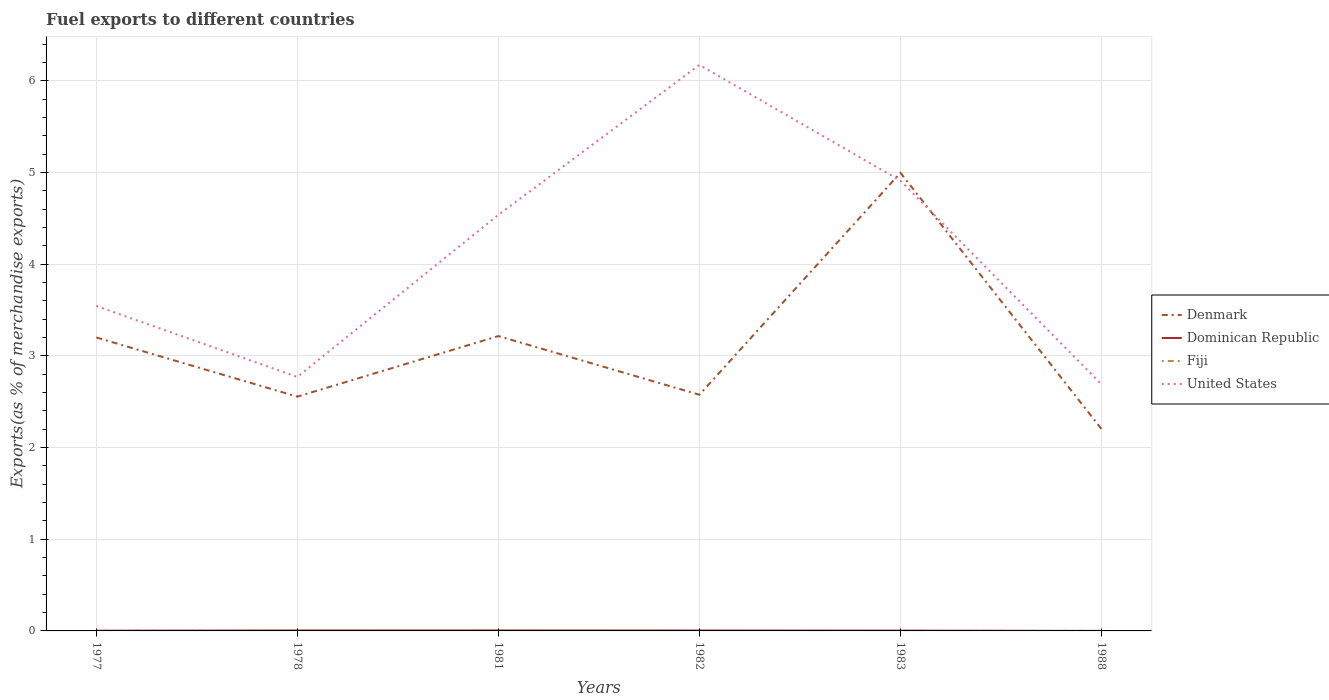How many different coloured lines are there?
Your response must be concise. 4. Does the line corresponding to Fiji intersect with the line corresponding to Dominican Republic?
Provide a short and direct response. Yes. Is the number of lines equal to the number of legend labels?
Give a very brief answer. Yes. Across all years, what is the maximum percentage of exports to different countries in Fiji?
Make the answer very short. 4.97172309888766e-5. In which year was the percentage of exports to different countries in United States maximum?
Your answer should be very brief. 1988. What is the total percentage of exports to different countries in United States in the graph?
Provide a short and direct response. -0.37. What is the difference between the highest and the second highest percentage of exports to different countries in Denmark?
Make the answer very short. 2.79. Is the percentage of exports to different countries in United States strictly greater than the percentage of exports to different countries in Denmark over the years?
Your answer should be compact. No. How many lines are there?
Your response must be concise. 4. How many years are there in the graph?
Offer a terse response. 6. Are the values on the major ticks of Y-axis written in scientific E-notation?
Offer a terse response. No. Does the graph contain any zero values?
Make the answer very short. No. Does the graph contain grids?
Provide a short and direct response. Yes. What is the title of the graph?
Your answer should be very brief. Fuel exports to different countries. Does "Burkina Faso" appear as one of the legend labels in the graph?
Give a very brief answer. No. What is the label or title of the X-axis?
Offer a very short reply. Years. What is the label or title of the Y-axis?
Your answer should be very brief. Exports(as % of merchandise exports). What is the Exports(as % of merchandise exports) in Denmark in 1977?
Your answer should be compact. 3.2. What is the Exports(as % of merchandise exports) in Dominican Republic in 1977?
Give a very brief answer. 0. What is the Exports(as % of merchandise exports) in Fiji in 1977?
Make the answer very short. 0. What is the Exports(as % of merchandise exports) of United States in 1977?
Your answer should be compact. 3.54. What is the Exports(as % of merchandise exports) in Denmark in 1978?
Give a very brief answer. 2.56. What is the Exports(as % of merchandise exports) in Dominican Republic in 1978?
Provide a short and direct response. 0. What is the Exports(as % of merchandise exports) of Fiji in 1978?
Offer a terse response. 0. What is the Exports(as % of merchandise exports) of United States in 1978?
Give a very brief answer. 2.77. What is the Exports(as % of merchandise exports) in Denmark in 1981?
Your answer should be very brief. 3.22. What is the Exports(as % of merchandise exports) of Dominican Republic in 1981?
Provide a short and direct response. 0.01. What is the Exports(as % of merchandise exports) of Fiji in 1981?
Ensure brevity in your answer.  0. What is the Exports(as % of merchandise exports) of United States in 1981?
Keep it short and to the point. 4.54. What is the Exports(as % of merchandise exports) in Denmark in 1982?
Offer a very short reply. 2.58. What is the Exports(as % of merchandise exports) in Dominican Republic in 1982?
Your response must be concise. 0. What is the Exports(as % of merchandise exports) of Fiji in 1982?
Your response must be concise. 4.97172309888766e-5. What is the Exports(as % of merchandise exports) of United States in 1982?
Give a very brief answer. 6.17. What is the Exports(as % of merchandise exports) in Denmark in 1983?
Ensure brevity in your answer.  5. What is the Exports(as % of merchandise exports) in Dominican Republic in 1983?
Ensure brevity in your answer.  0. What is the Exports(as % of merchandise exports) of Fiji in 1983?
Offer a very short reply. 0. What is the Exports(as % of merchandise exports) in United States in 1983?
Give a very brief answer. 4.91. What is the Exports(as % of merchandise exports) of Denmark in 1988?
Offer a terse response. 2.2. What is the Exports(as % of merchandise exports) in Dominican Republic in 1988?
Offer a terse response. 0. What is the Exports(as % of merchandise exports) of Fiji in 1988?
Provide a succinct answer. 0. What is the Exports(as % of merchandise exports) in United States in 1988?
Offer a very short reply. 2.69. Across all years, what is the maximum Exports(as % of merchandise exports) in Denmark?
Provide a succinct answer. 5. Across all years, what is the maximum Exports(as % of merchandise exports) of Dominican Republic?
Give a very brief answer. 0.01. Across all years, what is the maximum Exports(as % of merchandise exports) in Fiji?
Provide a succinct answer. 0. Across all years, what is the maximum Exports(as % of merchandise exports) of United States?
Your answer should be very brief. 6.17. Across all years, what is the minimum Exports(as % of merchandise exports) of Denmark?
Your response must be concise. 2.2. Across all years, what is the minimum Exports(as % of merchandise exports) in Dominican Republic?
Provide a succinct answer. 0. Across all years, what is the minimum Exports(as % of merchandise exports) in Fiji?
Your answer should be very brief. 4.97172309888766e-5. Across all years, what is the minimum Exports(as % of merchandise exports) of United States?
Provide a short and direct response. 2.69. What is the total Exports(as % of merchandise exports) in Denmark in the graph?
Offer a very short reply. 18.75. What is the total Exports(as % of merchandise exports) of Dominican Republic in the graph?
Ensure brevity in your answer.  0.02. What is the total Exports(as % of merchandise exports) in Fiji in the graph?
Your answer should be very brief. 0. What is the total Exports(as % of merchandise exports) of United States in the graph?
Your answer should be compact. 24.62. What is the difference between the Exports(as % of merchandise exports) in Denmark in 1977 and that in 1978?
Keep it short and to the point. 0.65. What is the difference between the Exports(as % of merchandise exports) in Dominican Republic in 1977 and that in 1978?
Your answer should be very brief. -0. What is the difference between the Exports(as % of merchandise exports) of Fiji in 1977 and that in 1978?
Your answer should be compact. 0. What is the difference between the Exports(as % of merchandise exports) in United States in 1977 and that in 1978?
Your answer should be very brief. 0.77. What is the difference between the Exports(as % of merchandise exports) in Denmark in 1977 and that in 1981?
Ensure brevity in your answer.  -0.02. What is the difference between the Exports(as % of merchandise exports) in Dominican Republic in 1977 and that in 1981?
Provide a succinct answer. -0. What is the difference between the Exports(as % of merchandise exports) of Fiji in 1977 and that in 1981?
Give a very brief answer. 0. What is the difference between the Exports(as % of merchandise exports) in United States in 1977 and that in 1981?
Keep it short and to the point. -0.99. What is the difference between the Exports(as % of merchandise exports) of Denmark in 1977 and that in 1982?
Your answer should be compact. 0.62. What is the difference between the Exports(as % of merchandise exports) of Dominican Republic in 1977 and that in 1982?
Make the answer very short. -0. What is the difference between the Exports(as % of merchandise exports) of Fiji in 1977 and that in 1982?
Give a very brief answer. 0. What is the difference between the Exports(as % of merchandise exports) in United States in 1977 and that in 1982?
Offer a terse response. -2.63. What is the difference between the Exports(as % of merchandise exports) of Denmark in 1977 and that in 1983?
Your answer should be compact. -1.8. What is the difference between the Exports(as % of merchandise exports) in Dominican Republic in 1977 and that in 1983?
Offer a very short reply. -0. What is the difference between the Exports(as % of merchandise exports) of Fiji in 1977 and that in 1983?
Offer a terse response. 0. What is the difference between the Exports(as % of merchandise exports) in United States in 1977 and that in 1983?
Ensure brevity in your answer.  -1.37. What is the difference between the Exports(as % of merchandise exports) of Dominican Republic in 1977 and that in 1988?
Your response must be concise. 0. What is the difference between the Exports(as % of merchandise exports) of Fiji in 1977 and that in 1988?
Keep it short and to the point. 0. What is the difference between the Exports(as % of merchandise exports) in United States in 1977 and that in 1988?
Your response must be concise. 0.85. What is the difference between the Exports(as % of merchandise exports) of Denmark in 1978 and that in 1981?
Make the answer very short. -0.66. What is the difference between the Exports(as % of merchandise exports) of Dominican Republic in 1978 and that in 1981?
Ensure brevity in your answer.  -0. What is the difference between the Exports(as % of merchandise exports) in United States in 1978 and that in 1981?
Keep it short and to the point. -1.77. What is the difference between the Exports(as % of merchandise exports) of Denmark in 1978 and that in 1982?
Offer a terse response. -0.02. What is the difference between the Exports(as % of merchandise exports) of Dominican Republic in 1978 and that in 1982?
Ensure brevity in your answer.  0. What is the difference between the Exports(as % of merchandise exports) of Fiji in 1978 and that in 1982?
Provide a short and direct response. 0. What is the difference between the Exports(as % of merchandise exports) of United States in 1978 and that in 1982?
Your response must be concise. -3.4. What is the difference between the Exports(as % of merchandise exports) of Denmark in 1978 and that in 1983?
Provide a succinct answer. -2.44. What is the difference between the Exports(as % of merchandise exports) in Dominican Republic in 1978 and that in 1983?
Ensure brevity in your answer.  0. What is the difference between the Exports(as % of merchandise exports) of United States in 1978 and that in 1983?
Your answer should be very brief. -2.14. What is the difference between the Exports(as % of merchandise exports) of Denmark in 1978 and that in 1988?
Keep it short and to the point. 0.35. What is the difference between the Exports(as % of merchandise exports) in Dominican Republic in 1978 and that in 1988?
Your response must be concise. 0. What is the difference between the Exports(as % of merchandise exports) in United States in 1978 and that in 1988?
Provide a short and direct response. 0.08. What is the difference between the Exports(as % of merchandise exports) of Denmark in 1981 and that in 1982?
Your answer should be compact. 0.64. What is the difference between the Exports(as % of merchandise exports) of Dominican Republic in 1981 and that in 1982?
Your response must be concise. 0. What is the difference between the Exports(as % of merchandise exports) in Fiji in 1981 and that in 1982?
Your answer should be very brief. 0. What is the difference between the Exports(as % of merchandise exports) in United States in 1981 and that in 1982?
Your answer should be compact. -1.64. What is the difference between the Exports(as % of merchandise exports) in Denmark in 1981 and that in 1983?
Make the answer very short. -1.78. What is the difference between the Exports(as % of merchandise exports) in Dominican Republic in 1981 and that in 1983?
Provide a short and direct response. 0. What is the difference between the Exports(as % of merchandise exports) in United States in 1981 and that in 1983?
Your response must be concise. -0.37. What is the difference between the Exports(as % of merchandise exports) in Denmark in 1981 and that in 1988?
Offer a terse response. 1.01. What is the difference between the Exports(as % of merchandise exports) in Dominican Republic in 1981 and that in 1988?
Your answer should be very brief. 0.01. What is the difference between the Exports(as % of merchandise exports) of Fiji in 1981 and that in 1988?
Offer a very short reply. 0. What is the difference between the Exports(as % of merchandise exports) of United States in 1981 and that in 1988?
Offer a terse response. 1.85. What is the difference between the Exports(as % of merchandise exports) in Denmark in 1982 and that in 1983?
Offer a terse response. -2.42. What is the difference between the Exports(as % of merchandise exports) in Dominican Republic in 1982 and that in 1983?
Provide a succinct answer. 0. What is the difference between the Exports(as % of merchandise exports) in Fiji in 1982 and that in 1983?
Ensure brevity in your answer.  -0. What is the difference between the Exports(as % of merchandise exports) of United States in 1982 and that in 1983?
Give a very brief answer. 1.26. What is the difference between the Exports(as % of merchandise exports) in Denmark in 1982 and that in 1988?
Ensure brevity in your answer.  0.37. What is the difference between the Exports(as % of merchandise exports) in Dominican Republic in 1982 and that in 1988?
Keep it short and to the point. 0. What is the difference between the Exports(as % of merchandise exports) in Fiji in 1982 and that in 1988?
Give a very brief answer. -0. What is the difference between the Exports(as % of merchandise exports) of United States in 1982 and that in 1988?
Your answer should be compact. 3.48. What is the difference between the Exports(as % of merchandise exports) in Denmark in 1983 and that in 1988?
Keep it short and to the point. 2.79. What is the difference between the Exports(as % of merchandise exports) of Dominican Republic in 1983 and that in 1988?
Provide a succinct answer. 0. What is the difference between the Exports(as % of merchandise exports) of United States in 1983 and that in 1988?
Keep it short and to the point. 2.22. What is the difference between the Exports(as % of merchandise exports) in Denmark in 1977 and the Exports(as % of merchandise exports) in Dominican Republic in 1978?
Provide a succinct answer. 3.2. What is the difference between the Exports(as % of merchandise exports) of Denmark in 1977 and the Exports(as % of merchandise exports) of Fiji in 1978?
Your response must be concise. 3.2. What is the difference between the Exports(as % of merchandise exports) of Denmark in 1977 and the Exports(as % of merchandise exports) of United States in 1978?
Offer a terse response. 0.43. What is the difference between the Exports(as % of merchandise exports) in Dominican Republic in 1977 and the Exports(as % of merchandise exports) in Fiji in 1978?
Your answer should be compact. 0. What is the difference between the Exports(as % of merchandise exports) of Dominican Republic in 1977 and the Exports(as % of merchandise exports) of United States in 1978?
Provide a short and direct response. -2.77. What is the difference between the Exports(as % of merchandise exports) of Fiji in 1977 and the Exports(as % of merchandise exports) of United States in 1978?
Your response must be concise. -2.77. What is the difference between the Exports(as % of merchandise exports) of Denmark in 1977 and the Exports(as % of merchandise exports) of Dominican Republic in 1981?
Provide a succinct answer. 3.2. What is the difference between the Exports(as % of merchandise exports) in Denmark in 1977 and the Exports(as % of merchandise exports) in Fiji in 1981?
Your answer should be compact. 3.2. What is the difference between the Exports(as % of merchandise exports) of Denmark in 1977 and the Exports(as % of merchandise exports) of United States in 1981?
Provide a succinct answer. -1.34. What is the difference between the Exports(as % of merchandise exports) of Dominican Republic in 1977 and the Exports(as % of merchandise exports) of Fiji in 1981?
Your answer should be compact. 0. What is the difference between the Exports(as % of merchandise exports) in Dominican Republic in 1977 and the Exports(as % of merchandise exports) in United States in 1981?
Give a very brief answer. -4.54. What is the difference between the Exports(as % of merchandise exports) of Fiji in 1977 and the Exports(as % of merchandise exports) of United States in 1981?
Keep it short and to the point. -4.54. What is the difference between the Exports(as % of merchandise exports) in Denmark in 1977 and the Exports(as % of merchandise exports) in Dominican Republic in 1982?
Your answer should be very brief. 3.2. What is the difference between the Exports(as % of merchandise exports) of Denmark in 1977 and the Exports(as % of merchandise exports) of Fiji in 1982?
Keep it short and to the point. 3.2. What is the difference between the Exports(as % of merchandise exports) in Denmark in 1977 and the Exports(as % of merchandise exports) in United States in 1982?
Offer a very short reply. -2.97. What is the difference between the Exports(as % of merchandise exports) of Dominican Republic in 1977 and the Exports(as % of merchandise exports) of Fiji in 1982?
Provide a short and direct response. 0. What is the difference between the Exports(as % of merchandise exports) of Dominican Republic in 1977 and the Exports(as % of merchandise exports) of United States in 1982?
Offer a very short reply. -6.17. What is the difference between the Exports(as % of merchandise exports) of Fiji in 1977 and the Exports(as % of merchandise exports) of United States in 1982?
Your answer should be compact. -6.17. What is the difference between the Exports(as % of merchandise exports) of Denmark in 1977 and the Exports(as % of merchandise exports) of Dominican Republic in 1983?
Your answer should be compact. 3.2. What is the difference between the Exports(as % of merchandise exports) in Denmark in 1977 and the Exports(as % of merchandise exports) in United States in 1983?
Make the answer very short. -1.71. What is the difference between the Exports(as % of merchandise exports) of Dominican Republic in 1977 and the Exports(as % of merchandise exports) of Fiji in 1983?
Offer a very short reply. 0. What is the difference between the Exports(as % of merchandise exports) in Dominican Republic in 1977 and the Exports(as % of merchandise exports) in United States in 1983?
Your answer should be compact. -4.91. What is the difference between the Exports(as % of merchandise exports) of Fiji in 1977 and the Exports(as % of merchandise exports) of United States in 1983?
Your response must be concise. -4.91. What is the difference between the Exports(as % of merchandise exports) of Denmark in 1977 and the Exports(as % of merchandise exports) of Dominican Republic in 1988?
Make the answer very short. 3.2. What is the difference between the Exports(as % of merchandise exports) of Denmark in 1977 and the Exports(as % of merchandise exports) of Fiji in 1988?
Provide a succinct answer. 3.2. What is the difference between the Exports(as % of merchandise exports) in Denmark in 1977 and the Exports(as % of merchandise exports) in United States in 1988?
Your response must be concise. 0.51. What is the difference between the Exports(as % of merchandise exports) of Dominican Republic in 1977 and the Exports(as % of merchandise exports) of Fiji in 1988?
Provide a succinct answer. 0. What is the difference between the Exports(as % of merchandise exports) of Dominican Republic in 1977 and the Exports(as % of merchandise exports) of United States in 1988?
Make the answer very short. -2.69. What is the difference between the Exports(as % of merchandise exports) of Fiji in 1977 and the Exports(as % of merchandise exports) of United States in 1988?
Offer a very short reply. -2.69. What is the difference between the Exports(as % of merchandise exports) of Denmark in 1978 and the Exports(as % of merchandise exports) of Dominican Republic in 1981?
Offer a terse response. 2.55. What is the difference between the Exports(as % of merchandise exports) in Denmark in 1978 and the Exports(as % of merchandise exports) in Fiji in 1981?
Give a very brief answer. 2.55. What is the difference between the Exports(as % of merchandise exports) of Denmark in 1978 and the Exports(as % of merchandise exports) of United States in 1981?
Your response must be concise. -1.98. What is the difference between the Exports(as % of merchandise exports) in Dominican Republic in 1978 and the Exports(as % of merchandise exports) in Fiji in 1981?
Offer a terse response. 0. What is the difference between the Exports(as % of merchandise exports) in Dominican Republic in 1978 and the Exports(as % of merchandise exports) in United States in 1981?
Keep it short and to the point. -4.53. What is the difference between the Exports(as % of merchandise exports) in Fiji in 1978 and the Exports(as % of merchandise exports) in United States in 1981?
Your answer should be very brief. -4.54. What is the difference between the Exports(as % of merchandise exports) in Denmark in 1978 and the Exports(as % of merchandise exports) in Dominican Republic in 1982?
Ensure brevity in your answer.  2.55. What is the difference between the Exports(as % of merchandise exports) of Denmark in 1978 and the Exports(as % of merchandise exports) of Fiji in 1982?
Provide a short and direct response. 2.56. What is the difference between the Exports(as % of merchandise exports) in Denmark in 1978 and the Exports(as % of merchandise exports) in United States in 1982?
Make the answer very short. -3.62. What is the difference between the Exports(as % of merchandise exports) of Dominican Republic in 1978 and the Exports(as % of merchandise exports) of Fiji in 1982?
Provide a short and direct response. 0. What is the difference between the Exports(as % of merchandise exports) of Dominican Republic in 1978 and the Exports(as % of merchandise exports) of United States in 1982?
Offer a very short reply. -6.17. What is the difference between the Exports(as % of merchandise exports) in Fiji in 1978 and the Exports(as % of merchandise exports) in United States in 1982?
Offer a very short reply. -6.17. What is the difference between the Exports(as % of merchandise exports) of Denmark in 1978 and the Exports(as % of merchandise exports) of Dominican Republic in 1983?
Make the answer very short. 2.55. What is the difference between the Exports(as % of merchandise exports) in Denmark in 1978 and the Exports(as % of merchandise exports) in Fiji in 1983?
Provide a short and direct response. 2.55. What is the difference between the Exports(as % of merchandise exports) in Denmark in 1978 and the Exports(as % of merchandise exports) in United States in 1983?
Your answer should be compact. -2.36. What is the difference between the Exports(as % of merchandise exports) of Dominican Republic in 1978 and the Exports(as % of merchandise exports) of Fiji in 1983?
Make the answer very short. 0. What is the difference between the Exports(as % of merchandise exports) of Dominican Republic in 1978 and the Exports(as % of merchandise exports) of United States in 1983?
Your response must be concise. -4.91. What is the difference between the Exports(as % of merchandise exports) of Fiji in 1978 and the Exports(as % of merchandise exports) of United States in 1983?
Your answer should be very brief. -4.91. What is the difference between the Exports(as % of merchandise exports) of Denmark in 1978 and the Exports(as % of merchandise exports) of Dominican Republic in 1988?
Give a very brief answer. 2.56. What is the difference between the Exports(as % of merchandise exports) of Denmark in 1978 and the Exports(as % of merchandise exports) of Fiji in 1988?
Keep it short and to the point. 2.55. What is the difference between the Exports(as % of merchandise exports) of Denmark in 1978 and the Exports(as % of merchandise exports) of United States in 1988?
Your response must be concise. -0.13. What is the difference between the Exports(as % of merchandise exports) of Dominican Republic in 1978 and the Exports(as % of merchandise exports) of Fiji in 1988?
Your answer should be compact. 0. What is the difference between the Exports(as % of merchandise exports) in Dominican Republic in 1978 and the Exports(as % of merchandise exports) in United States in 1988?
Your response must be concise. -2.68. What is the difference between the Exports(as % of merchandise exports) in Fiji in 1978 and the Exports(as % of merchandise exports) in United States in 1988?
Ensure brevity in your answer.  -2.69. What is the difference between the Exports(as % of merchandise exports) in Denmark in 1981 and the Exports(as % of merchandise exports) in Dominican Republic in 1982?
Make the answer very short. 3.21. What is the difference between the Exports(as % of merchandise exports) in Denmark in 1981 and the Exports(as % of merchandise exports) in Fiji in 1982?
Provide a short and direct response. 3.22. What is the difference between the Exports(as % of merchandise exports) in Denmark in 1981 and the Exports(as % of merchandise exports) in United States in 1982?
Give a very brief answer. -2.96. What is the difference between the Exports(as % of merchandise exports) in Dominican Republic in 1981 and the Exports(as % of merchandise exports) in Fiji in 1982?
Give a very brief answer. 0.01. What is the difference between the Exports(as % of merchandise exports) of Dominican Republic in 1981 and the Exports(as % of merchandise exports) of United States in 1982?
Provide a succinct answer. -6.17. What is the difference between the Exports(as % of merchandise exports) of Fiji in 1981 and the Exports(as % of merchandise exports) of United States in 1982?
Your response must be concise. -6.17. What is the difference between the Exports(as % of merchandise exports) of Denmark in 1981 and the Exports(as % of merchandise exports) of Dominican Republic in 1983?
Offer a terse response. 3.21. What is the difference between the Exports(as % of merchandise exports) of Denmark in 1981 and the Exports(as % of merchandise exports) of Fiji in 1983?
Provide a succinct answer. 3.22. What is the difference between the Exports(as % of merchandise exports) in Denmark in 1981 and the Exports(as % of merchandise exports) in United States in 1983?
Ensure brevity in your answer.  -1.69. What is the difference between the Exports(as % of merchandise exports) in Dominican Republic in 1981 and the Exports(as % of merchandise exports) in Fiji in 1983?
Your response must be concise. 0. What is the difference between the Exports(as % of merchandise exports) in Dominican Republic in 1981 and the Exports(as % of merchandise exports) in United States in 1983?
Give a very brief answer. -4.91. What is the difference between the Exports(as % of merchandise exports) of Fiji in 1981 and the Exports(as % of merchandise exports) of United States in 1983?
Provide a short and direct response. -4.91. What is the difference between the Exports(as % of merchandise exports) of Denmark in 1981 and the Exports(as % of merchandise exports) of Dominican Republic in 1988?
Offer a terse response. 3.22. What is the difference between the Exports(as % of merchandise exports) in Denmark in 1981 and the Exports(as % of merchandise exports) in Fiji in 1988?
Offer a very short reply. 3.22. What is the difference between the Exports(as % of merchandise exports) of Denmark in 1981 and the Exports(as % of merchandise exports) of United States in 1988?
Your answer should be very brief. 0.53. What is the difference between the Exports(as % of merchandise exports) in Dominican Republic in 1981 and the Exports(as % of merchandise exports) in Fiji in 1988?
Keep it short and to the point. 0. What is the difference between the Exports(as % of merchandise exports) of Dominican Republic in 1981 and the Exports(as % of merchandise exports) of United States in 1988?
Make the answer very short. -2.68. What is the difference between the Exports(as % of merchandise exports) of Fiji in 1981 and the Exports(as % of merchandise exports) of United States in 1988?
Provide a succinct answer. -2.69. What is the difference between the Exports(as % of merchandise exports) of Denmark in 1982 and the Exports(as % of merchandise exports) of Dominican Republic in 1983?
Keep it short and to the point. 2.57. What is the difference between the Exports(as % of merchandise exports) in Denmark in 1982 and the Exports(as % of merchandise exports) in Fiji in 1983?
Your answer should be compact. 2.58. What is the difference between the Exports(as % of merchandise exports) in Denmark in 1982 and the Exports(as % of merchandise exports) in United States in 1983?
Your answer should be very brief. -2.33. What is the difference between the Exports(as % of merchandise exports) of Dominican Republic in 1982 and the Exports(as % of merchandise exports) of Fiji in 1983?
Your answer should be very brief. 0. What is the difference between the Exports(as % of merchandise exports) of Dominican Republic in 1982 and the Exports(as % of merchandise exports) of United States in 1983?
Give a very brief answer. -4.91. What is the difference between the Exports(as % of merchandise exports) of Fiji in 1982 and the Exports(as % of merchandise exports) of United States in 1983?
Provide a succinct answer. -4.91. What is the difference between the Exports(as % of merchandise exports) in Denmark in 1982 and the Exports(as % of merchandise exports) in Dominican Republic in 1988?
Provide a short and direct response. 2.58. What is the difference between the Exports(as % of merchandise exports) in Denmark in 1982 and the Exports(as % of merchandise exports) in Fiji in 1988?
Provide a short and direct response. 2.58. What is the difference between the Exports(as % of merchandise exports) in Denmark in 1982 and the Exports(as % of merchandise exports) in United States in 1988?
Make the answer very short. -0.11. What is the difference between the Exports(as % of merchandise exports) in Dominican Republic in 1982 and the Exports(as % of merchandise exports) in Fiji in 1988?
Your response must be concise. 0. What is the difference between the Exports(as % of merchandise exports) in Dominican Republic in 1982 and the Exports(as % of merchandise exports) in United States in 1988?
Your answer should be very brief. -2.69. What is the difference between the Exports(as % of merchandise exports) of Fiji in 1982 and the Exports(as % of merchandise exports) of United States in 1988?
Give a very brief answer. -2.69. What is the difference between the Exports(as % of merchandise exports) of Denmark in 1983 and the Exports(as % of merchandise exports) of Dominican Republic in 1988?
Ensure brevity in your answer.  5. What is the difference between the Exports(as % of merchandise exports) in Denmark in 1983 and the Exports(as % of merchandise exports) in Fiji in 1988?
Your answer should be very brief. 5. What is the difference between the Exports(as % of merchandise exports) in Denmark in 1983 and the Exports(as % of merchandise exports) in United States in 1988?
Make the answer very short. 2.31. What is the difference between the Exports(as % of merchandise exports) in Dominican Republic in 1983 and the Exports(as % of merchandise exports) in Fiji in 1988?
Provide a short and direct response. 0. What is the difference between the Exports(as % of merchandise exports) in Dominican Republic in 1983 and the Exports(as % of merchandise exports) in United States in 1988?
Ensure brevity in your answer.  -2.69. What is the difference between the Exports(as % of merchandise exports) of Fiji in 1983 and the Exports(as % of merchandise exports) of United States in 1988?
Offer a terse response. -2.69. What is the average Exports(as % of merchandise exports) in Denmark per year?
Your answer should be compact. 3.12. What is the average Exports(as % of merchandise exports) of Dominican Republic per year?
Offer a terse response. 0. What is the average Exports(as % of merchandise exports) in Fiji per year?
Offer a terse response. 0. What is the average Exports(as % of merchandise exports) of United States per year?
Your answer should be very brief. 4.1. In the year 1977, what is the difference between the Exports(as % of merchandise exports) of Denmark and Exports(as % of merchandise exports) of Dominican Republic?
Your answer should be compact. 3.2. In the year 1977, what is the difference between the Exports(as % of merchandise exports) of Denmark and Exports(as % of merchandise exports) of Fiji?
Your answer should be compact. 3.2. In the year 1977, what is the difference between the Exports(as % of merchandise exports) of Denmark and Exports(as % of merchandise exports) of United States?
Your answer should be compact. -0.34. In the year 1977, what is the difference between the Exports(as % of merchandise exports) of Dominican Republic and Exports(as % of merchandise exports) of Fiji?
Provide a succinct answer. 0. In the year 1977, what is the difference between the Exports(as % of merchandise exports) in Dominican Republic and Exports(as % of merchandise exports) in United States?
Your answer should be very brief. -3.54. In the year 1977, what is the difference between the Exports(as % of merchandise exports) in Fiji and Exports(as % of merchandise exports) in United States?
Provide a succinct answer. -3.54. In the year 1978, what is the difference between the Exports(as % of merchandise exports) of Denmark and Exports(as % of merchandise exports) of Dominican Republic?
Keep it short and to the point. 2.55. In the year 1978, what is the difference between the Exports(as % of merchandise exports) in Denmark and Exports(as % of merchandise exports) in Fiji?
Offer a very short reply. 2.55. In the year 1978, what is the difference between the Exports(as % of merchandise exports) of Denmark and Exports(as % of merchandise exports) of United States?
Your answer should be compact. -0.21. In the year 1978, what is the difference between the Exports(as % of merchandise exports) of Dominican Republic and Exports(as % of merchandise exports) of Fiji?
Make the answer very short. 0. In the year 1978, what is the difference between the Exports(as % of merchandise exports) of Dominican Republic and Exports(as % of merchandise exports) of United States?
Make the answer very short. -2.77. In the year 1978, what is the difference between the Exports(as % of merchandise exports) in Fiji and Exports(as % of merchandise exports) in United States?
Provide a short and direct response. -2.77. In the year 1981, what is the difference between the Exports(as % of merchandise exports) in Denmark and Exports(as % of merchandise exports) in Dominican Republic?
Give a very brief answer. 3.21. In the year 1981, what is the difference between the Exports(as % of merchandise exports) of Denmark and Exports(as % of merchandise exports) of Fiji?
Provide a succinct answer. 3.21. In the year 1981, what is the difference between the Exports(as % of merchandise exports) in Denmark and Exports(as % of merchandise exports) in United States?
Provide a succinct answer. -1.32. In the year 1981, what is the difference between the Exports(as % of merchandise exports) in Dominican Republic and Exports(as % of merchandise exports) in Fiji?
Your answer should be very brief. 0. In the year 1981, what is the difference between the Exports(as % of merchandise exports) in Dominican Republic and Exports(as % of merchandise exports) in United States?
Your answer should be very brief. -4.53. In the year 1981, what is the difference between the Exports(as % of merchandise exports) in Fiji and Exports(as % of merchandise exports) in United States?
Provide a succinct answer. -4.54. In the year 1982, what is the difference between the Exports(as % of merchandise exports) in Denmark and Exports(as % of merchandise exports) in Dominican Republic?
Your response must be concise. 2.57. In the year 1982, what is the difference between the Exports(as % of merchandise exports) in Denmark and Exports(as % of merchandise exports) in Fiji?
Provide a succinct answer. 2.58. In the year 1982, what is the difference between the Exports(as % of merchandise exports) of Denmark and Exports(as % of merchandise exports) of United States?
Provide a succinct answer. -3.6. In the year 1982, what is the difference between the Exports(as % of merchandise exports) of Dominican Republic and Exports(as % of merchandise exports) of Fiji?
Provide a short and direct response. 0. In the year 1982, what is the difference between the Exports(as % of merchandise exports) of Dominican Republic and Exports(as % of merchandise exports) of United States?
Offer a terse response. -6.17. In the year 1982, what is the difference between the Exports(as % of merchandise exports) of Fiji and Exports(as % of merchandise exports) of United States?
Offer a very short reply. -6.17. In the year 1983, what is the difference between the Exports(as % of merchandise exports) of Denmark and Exports(as % of merchandise exports) of Dominican Republic?
Keep it short and to the point. 4.99. In the year 1983, what is the difference between the Exports(as % of merchandise exports) in Denmark and Exports(as % of merchandise exports) in Fiji?
Your answer should be compact. 5. In the year 1983, what is the difference between the Exports(as % of merchandise exports) in Denmark and Exports(as % of merchandise exports) in United States?
Your answer should be compact. 0.09. In the year 1983, what is the difference between the Exports(as % of merchandise exports) of Dominican Republic and Exports(as % of merchandise exports) of Fiji?
Keep it short and to the point. 0. In the year 1983, what is the difference between the Exports(as % of merchandise exports) in Dominican Republic and Exports(as % of merchandise exports) in United States?
Give a very brief answer. -4.91. In the year 1983, what is the difference between the Exports(as % of merchandise exports) in Fiji and Exports(as % of merchandise exports) in United States?
Provide a succinct answer. -4.91. In the year 1988, what is the difference between the Exports(as % of merchandise exports) of Denmark and Exports(as % of merchandise exports) of Dominican Republic?
Ensure brevity in your answer.  2.2. In the year 1988, what is the difference between the Exports(as % of merchandise exports) in Denmark and Exports(as % of merchandise exports) in Fiji?
Give a very brief answer. 2.2. In the year 1988, what is the difference between the Exports(as % of merchandise exports) in Denmark and Exports(as % of merchandise exports) in United States?
Keep it short and to the point. -0.49. In the year 1988, what is the difference between the Exports(as % of merchandise exports) in Dominican Republic and Exports(as % of merchandise exports) in Fiji?
Your answer should be compact. -0. In the year 1988, what is the difference between the Exports(as % of merchandise exports) of Dominican Republic and Exports(as % of merchandise exports) of United States?
Your answer should be compact. -2.69. In the year 1988, what is the difference between the Exports(as % of merchandise exports) of Fiji and Exports(as % of merchandise exports) of United States?
Make the answer very short. -2.69. What is the ratio of the Exports(as % of merchandise exports) of Denmark in 1977 to that in 1978?
Your response must be concise. 1.25. What is the ratio of the Exports(as % of merchandise exports) of Dominican Republic in 1977 to that in 1978?
Offer a very short reply. 0.4. What is the ratio of the Exports(as % of merchandise exports) of Fiji in 1977 to that in 1978?
Keep it short and to the point. 2.4. What is the ratio of the Exports(as % of merchandise exports) of United States in 1977 to that in 1978?
Ensure brevity in your answer.  1.28. What is the ratio of the Exports(as % of merchandise exports) in Denmark in 1977 to that in 1981?
Ensure brevity in your answer.  1. What is the ratio of the Exports(as % of merchandise exports) of Dominican Republic in 1977 to that in 1981?
Give a very brief answer. 0.38. What is the ratio of the Exports(as % of merchandise exports) in Fiji in 1977 to that in 1981?
Provide a succinct answer. 2.47. What is the ratio of the Exports(as % of merchandise exports) of United States in 1977 to that in 1981?
Your response must be concise. 0.78. What is the ratio of the Exports(as % of merchandise exports) in Denmark in 1977 to that in 1982?
Offer a very short reply. 1.24. What is the ratio of the Exports(as % of merchandise exports) of Dominican Republic in 1977 to that in 1982?
Provide a succinct answer. 0.45. What is the ratio of the Exports(as % of merchandise exports) of Fiji in 1977 to that in 1982?
Your answer should be compact. 29.11. What is the ratio of the Exports(as % of merchandise exports) in United States in 1977 to that in 1982?
Offer a terse response. 0.57. What is the ratio of the Exports(as % of merchandise exports) of Denmark in 1977 to that in 1983?
Make the answer very short. 0.64. What is the ratio of the Exports(as % of merchandise exports) of Dominican Republic in 1977 to that in 1983?
Keep it short and to the point. 0.63. What is the ratio of the Exports(as % of merchandise exports) of Fiji in 1977 to that in 1983?
Provide a short and direct response. 3.99. What is the ratio of the Exports(as % of merchandise exports) in United States in 1977 to that in 1983?
Offer a very short reply. 0.72. What is the ratio of the Exports(as % of merchandise exports) of Denmark in 1977 to that in 1988?
Offer a very short reply. 1.45. What is the ratio of the Exports(as % of merchandise exports) of Dominican Republic in 1977 to that in 1988?
Give a very brief answer. 10.42. What is the ratio of the Exports(as % of merchandise exports) in Fiji in 1977 to that in 1988?
Make the answer very short. 4.04. What is the ratio of the Exports(as % of merchandise exports) in United States in 1977 to that in 1988?
Give a very brief answer. 1.32. What is the ratio of the Exports(as % of merchandise exports) in Denmark in 1978 to that in 1981?
Your answer should be very brief. 0.79. What is the ratio of the Exports(as % of merchandise exports) of Dominican Republic in 1978 to that in 1981?
Make the answer very short. 0.94. What is the ratio of the Exports(as % of merchandise exports) of Fiji in 1978 to that in 1981?
Offer a very short reply. 1.03. What is the ratio of the Exports(as % of merchandise exports) in United States in 1978 to that in 1981?
Offer a very short reply. 0.61. What is the ratio of the Exports(as % of merchandise exports) in Denmark in 1978 to that in 1982?
Offer a very short reply. 0.99. What is the ratio of the Exports(as % of merchandise exports) in Dominican Republic in 1978 to that in 1982?
Keep it short and to the point. 1.13. What is the ratio of the Exports(as % of merchandise exports) of Fiji in 1978 to that in 1982?
Make the answer very short. 12.12. What is the ratio of the Exports(as % of merchandise exports) in United States in 1978 to that in 1982?
Make the answer very short. 0.45. What is the ratio of the Exports(as % of merchandise exports) in Denmark in 1978 to that in 1983?
Keep it short and to the point. 0.51. What is the ratio of the Exports(as % of merchandise exports) in Dominican Republic in 1978 to that in 1983?
Your answer should be compact. 1.56. What is the ratio of the Exports(as % of merchandise exports) of Fiji in 1978 to that in 1983?
Your response must be concise. 1.66. What is the ratio of the Exports(as % of merchandise exports) in United States in 1978 to that in 1983?
Keep it short and to the point. 0.56. What is the ratio of the Exports(as % of merchandise exports) in Denmark in 1978 to that in 1988?
Your answer should be very brief. 1.16. What is the ratio of the Exports(as % of merchandise exports) of Dominican Republic in 1978 to that in 1988?
Provide a succinct answer. 25.92. What is the ratio of the Exports(as % of merchandise exports) in Fiji in 1978 to that in 1988?
Keep it short and to the point. 1.68. What is the ratio of the Exports(as % of merchandise exports) of United States in 1978 to that in 1988?
Offer a very short reply. 1.03. What is the ratio of the Exports(as % of merchandise exports) of Denmark in 1981 to that in 1982?
Your answer should be compact. 1.25. What is the ratio of the Exports(as % of merchandise exports) in Dominican Republic in 1981 to that in 1982?
Your answer should be very brief. 1.2. What is the ratio of the Exports(as % of merchandise exports) in Fiji in 1981 to that in 1982?
Keep it short and to the point. 11.81. What is the ratio of the Exports(as % of merchandise exports) of United States in 1981 to that in 1982?
Make the answer very short. 0.73. What is the ratio of the Exports(as % of merchandise exports) in Denmark in 1981 to that in 1983?
Your answer should be compact. 0.64. What is the ratio of the Exports(as % of merchandise exports) of Dominican Republic in 1981 to that in 1983?
Give a very brief answer. 1.66. What is the ratio of the Exports(as % of merchandise exports) in Fiji in 1981 to that in 1983?
Your answer should be compact. 1.62. What is the ratio of the Exports(as % of merchandise exports) in United States in 1981 to that in 1983?
Make the answer very short. 0.92. What is the ratio of the Exports(as % of merchandise exports) in Denmark in 1981 to that in 1988?
Your answer should be compact. 1.46. What is the ratio of the Exports(as % of merchandise exports) in Dominican Republic in 1981 to that in 1988?
Offer a very short reply. 27.43. What is the ratio of the Exports(as % of merchandise exports) of Fiji in 1981 to that in 1988?
Make the answer very short. 1.64. What is the ratio of the Exports(as % of merchandise exports) in United States in 1981 to that in 1988?
Your response must be concise. 1.69. What is the ratio of the Exports(as % of merchandise exports) of Denmark in 1982 to that in 1983?
Your response must be concise. 0.52. What is the ratio of the Exports(as % of merchandise exports) in Dominican Republic in 1982 to that in 1983?
Keep it short and to the point. 1.38. What is the ratio of the Exports(as % of merchandise exports) in Fiji in 1982 to that in 1983?
Your answer should be compact. 0.14. What is the ratio of the Exports(as % of merchandise exports) in United States in 1982 to that in 1983?
Your response must be concise. 1.26. What is the ratio of the Exports(as % of merchandise exports) in Denmark in 1982 to that in 1988?
Provide a succinct answer. 1.17. What is the ratio of the Exports(as % of merchandise exports) in Dominican Republic in 1982 to that in 1988?
Offer a terse response. 22.93. What is the ratio of the Exports(as % of merchandise exports) of Fiji in 1982 to that in 1988?
Provide a succinct answer. 0.14. What is the ratio of the Exports(as % of merchandise exports) in United States in 1982 to that in 1988?
Provide a short and direct response. 2.3. What is the ratio of the Exports(as % of merchandise exports) of Denmark in 1983 to that in 1988?
Ensure brevity in your answer.  2.27. What is the ratio of the Exports(as % of merchandise exports) of Dominican Republic in 1983 to that in 1988?
Give a very brief answer. 16.57. What is the ratio of the Exports(as % of merchandise exports) in Fiji in 1983 to that in 1988?
Your response must be concise. 1.01. What is the ratio of the Exports(as % of merchandise exports) in United States in 1983 to that in 1988?
Your response must be concise. 1.83. What is the difference between the highest and the second highest Exports(as % of merchandise exports) of Denmark?
Your answer should be compact. 1.78. What is the difference between the highest and the second highest Exports(as % of merchandise exports) of Fiji?
Your answer should be compact. 0. What is the difference between the highest and the second highest Exports(as % of merchandise exports) in United States?
Ensure brevity in your answer.  1.26. What is the difference between the highest and the lowest Exports(as % of merchandise exports) of Denmark?
Make the answer very short. 2.79. What is the difference between the highest and the lowest Exports(as % of merchandise exports) of Dominican Republic?
Your answer should be very brief. 0.01. What is the difference between the highest and the lowest Exports(as % of merchandise exports) of Fiji?
Keep it short and to the point. 0. What is the difference between the highest and the lowest Exports(as % of merchandise exports) of United States?
Offer a very short reply. 3.48. 